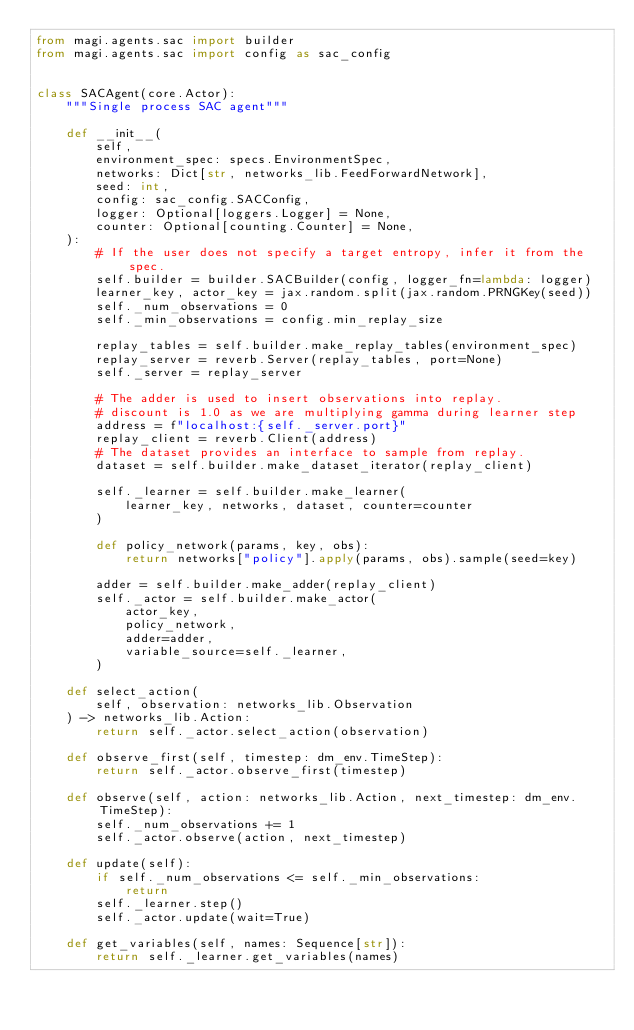Convert code to text. <code><loc_0><loc_0><loc_500><loc_500><_Python_>from magi.agents.sac import builder
from magi.agents.sac import config as sac_config


class SACAgent(core.Actor):
    """Single process SAC agent"""

    def __init__(
        self,
        environment_spec: specs.EnvironmentSpec,
        networks: Dict[str, networks_lib.FeedForwardNetwork],
        seed: int,
        config: sac_config.SACConfig,
        logger: Optional[loggers.Logger] = None,
        counter: Optional[counting.Counter] = None,
    ):
        # If the user does not specify a target entropy, infer it from the spec.
        self.builder = builder.SACBuilder(config, logger_fn=lambda: logger)
        learner_key, actor_key = jax.random.split(jax.random.PRNGKey(seed))
        self._num_observations = 0
        self._min_observations = config.min_replay_size

        replay_tables = self.builder.make_replay_tables(environment_spec)
        replay_server = reverb.Server(replay_tables, port=None)
        self._server = replay_server

        # The adder is used to insert observations into replay.
        # discount is 1.0 as we are multiplying gamma during learner step
        address = f"localhost:{self._server.port}"
        replay_client = reverb.Client(address)
        # The dataset provides an interface to sample from replay.
        dataset = self.builder.make_dataset_iterator(replay_client)

        self._learner = self.builder.make_learner(
            learner_key, networks, dataset, counter=counter
        )

        def policy_network(params, key, obs):
            return networks["policy"].apply(params, obs).sample(seed=key)

        adder = self.builder.make_adder(replay_client)
        self._actor = self.builder.make_actor(
            actor_key,
            policy_network,
            adder=adder,
            variable_source=self._learner,
        )

    def select_action(
        self, observation: networks_lib.Observation
    ) -> networks_lib.Action:
        return self._actor.select_action(observation)

    def observe_first(self, timestep: dm_env.TimeStep):
        return self._actor.observe_first(timestep)

    def observe(self, action: networks_lib.Action, next_timestep: dm_env.TimeStep):
        self._num_observations += 1
        self._actor.observe(action, next_timestep)

    def update(self):
        if self._num_observations <= self._min_observations:
            return
        self._learner.step()
        self._actor.update(wait=True)

    def get_variables(self, names: Sequence[str]):
        return self._learner.get_variables(names)
</code> 